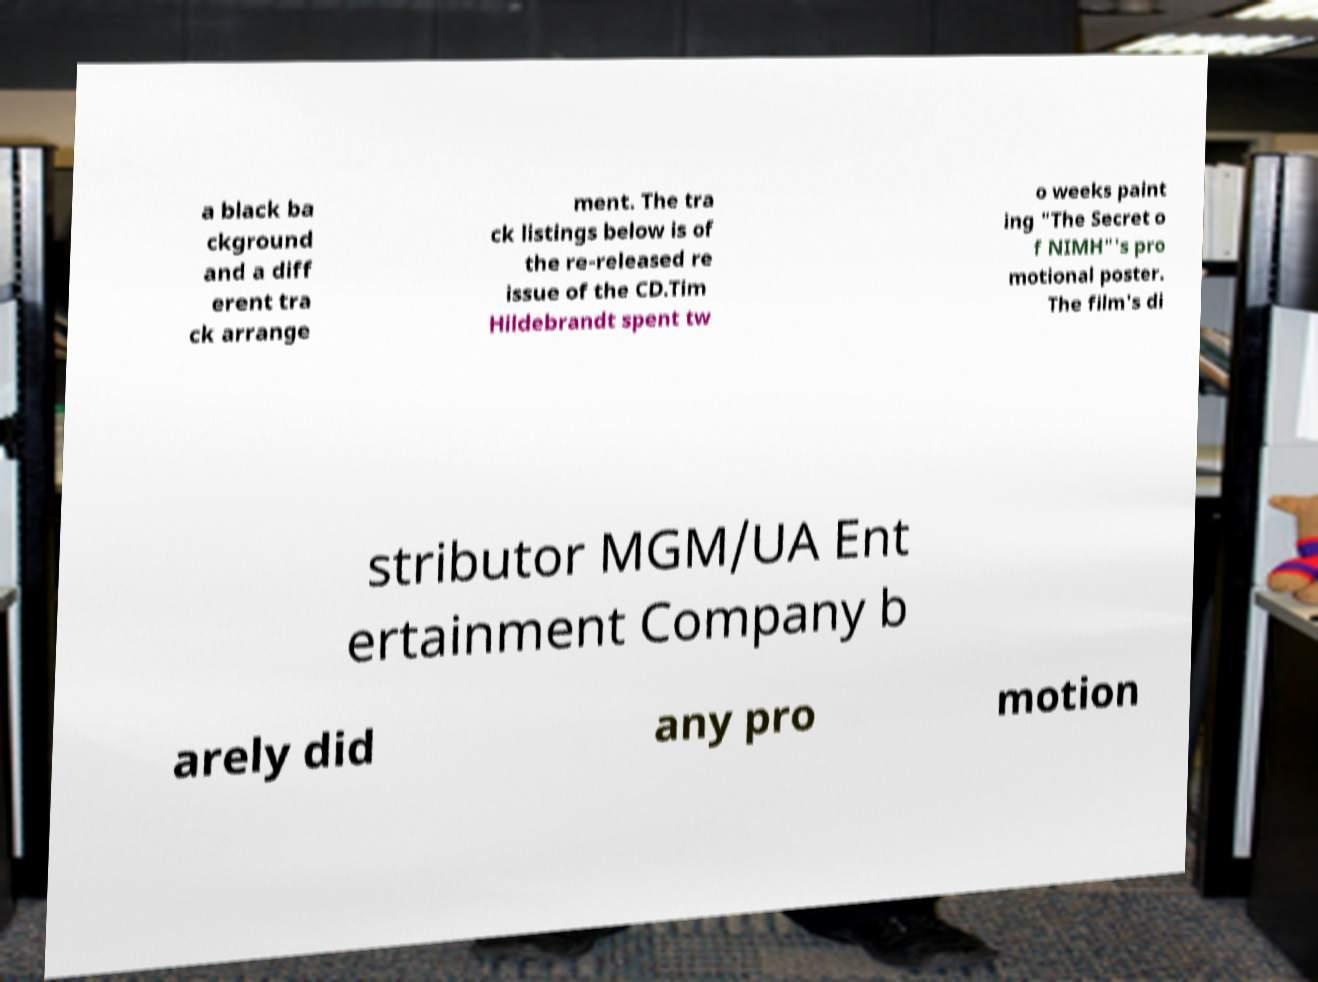Please identify and transcribe the text found in this image. a black ba ckground and a diff erent tra ck arrange ment. The tra ck listings below is of the re-released re issue of the CD.Tim Hildebrandt spent tw o weeks paint ing "The Secret o f NIMH"'s pro motional poster. The film's di stributor MGM/UA Ent ertainment Company b arely did any pro motion 